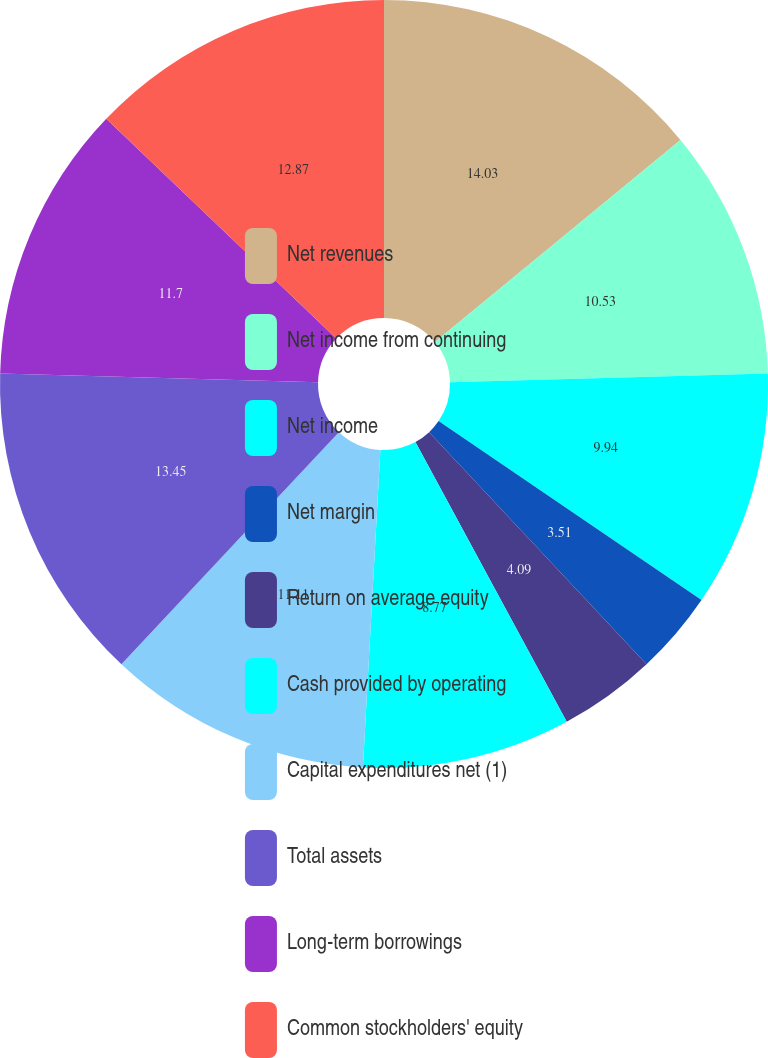<chart> <loc_0><loc_0><loc_500><loc_500><pie_chart><fcel>Net revenues<fcel>Net income from continuing<fcel>Net income<fcel>Net margin<fcel>Return on average equity<fcel>Cash provided by operating<fcel>Capital expenditures net (1)<fcel>Total assets<fcel>Long-term borrowings<fcel>Common stockholders' equity<nl><fcel>14.04%<fcel>10.53%<fcel>9.94%<fcel>3.51%<fcel>4.09%<fcel>8.77%<fcel>11.11%<fcel>13.45%<fcel>11.7%<fcel>12.87%<nl></chart> 